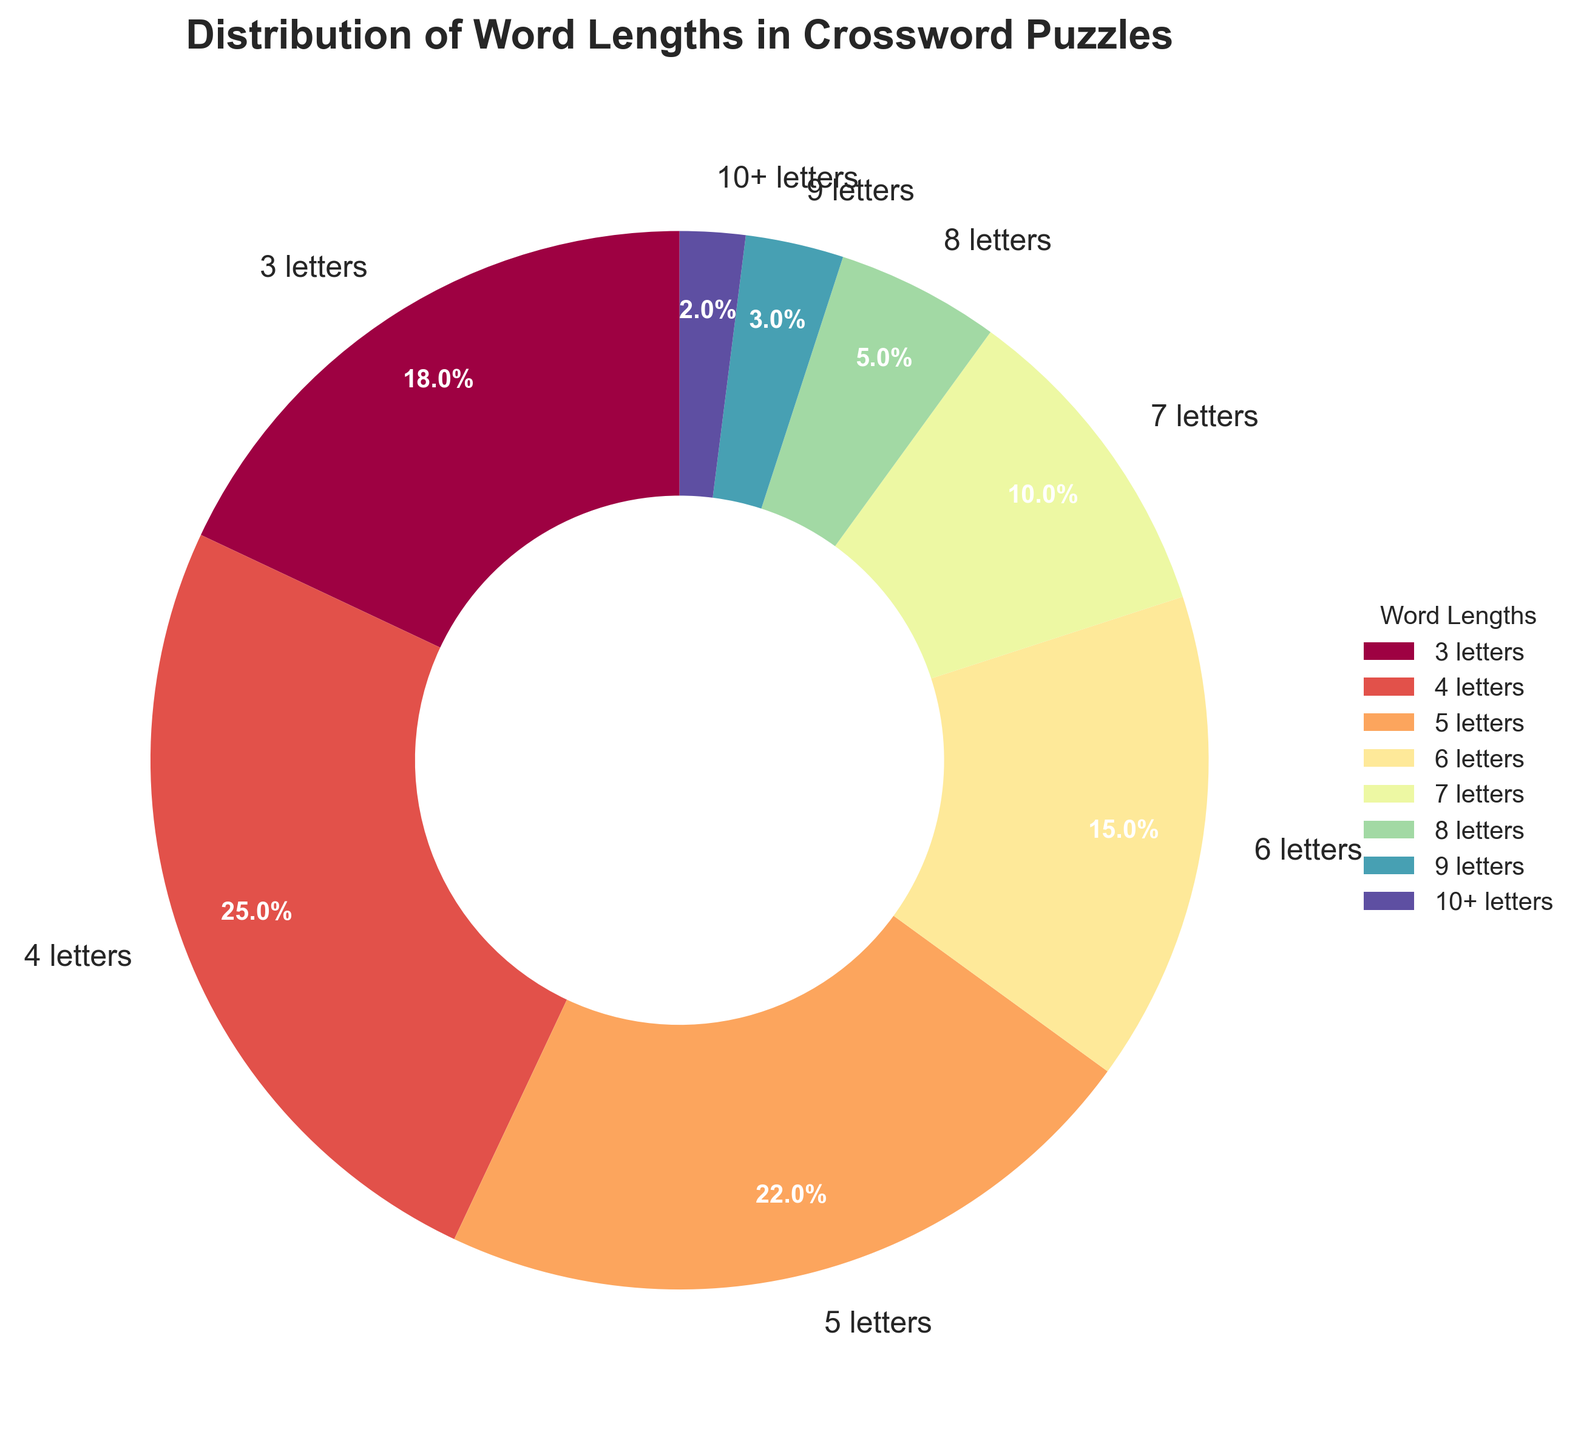What is the most common word length in the puzzle? The largest percentage in the pie chart is labeled as '4 letters' with 25%. Therefore, the most common word length is 4 letters.
Answer: 4 letters Which word length has the smallest representation? The segment labeled '10+ letters' has the smallest percentage of 2%.
Answer: 10+ letters How does the percentage of 3-letter words compare to 8-letter words? The percentage of 3-letter words is 18%, and the percentage of 8-letter words is 5%. 18% is significantly larger than 5%.
Answer: 3-letter words are more common What is the combined percentage of words that are either 5 or 6 letters long? To find the combined percentage, add the percentages of 5-letter words (22%) and 6-letter words (15%). 22 + 15 = 37.
Answer: 37% Are there more 7-letter words or 9-letter words in the puzzle? The pie chart shows that 7-letter words make up 10% and 9-letter words make up 3%. Since 10% is greater than 3%, there are more 7-letter words.
Answer: 7-letter words By how much does the percentage of 4-letter words exceed that of 3-letter words? The percentage of 4-letter words is 25%, and the percentage of 3-letter words is 18%. The difference is 25 - 18 = 7.
Answer: 7% Which word lengths make up more than a quarter of the puzzle when combined? Sum the percentages of 3-letter words (18%) and 4-letter words (25%), which are the two largest segments. 18 + 25 = 43. This exceeds a quarter (25%).
Answer: 3-letter and 4-letter words What is the total percentage for words that are 6 letters or longer? To find the total percentage for words 6 letters or longer, sum the percentages of 6-letter (15%), 7-letter (10%), 8-letter (5%), 9-letter (3%), and 10+ letter (2%) words. 15 + 10 + 5 + 3 + 2 = 35.
Answer: 35% Compare the visual sizes of the pie segments for 4-letter words and 6-letter words. Which one is larger and by how much? The segment for 4-letter words is 25%, and the segment for 6-letter words is 15%. Visually, the 4-letter segment is larger, and the difference is 25 - 15 = 10.
Answer: 4-letter words are larger by 10% 